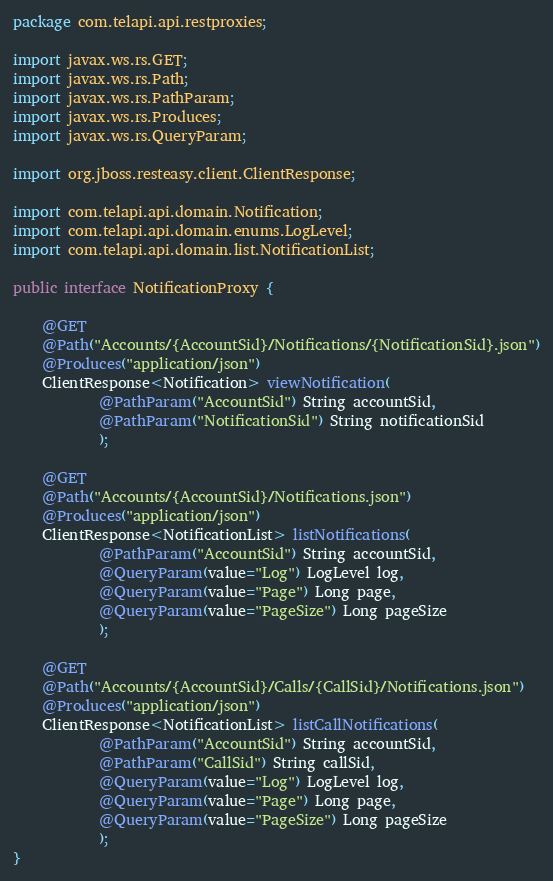Convert code to text. <code><loc_0><loc_0><loc_500><loc_500><_Java_>package com.telapi.api.restproxies;

import javax.ws.rs.GET;
import javax.ws.rs.Path;
import javax.ws.rs.PathParam;
import javax.ws.rs.Produces;
import javax.ws.rs.QueryParam;

import org.jboss.resteasy.client.ClientResponse;

import com.telapi.api.domain.Notification;
import com.telapi.api.domain.enums.LogLevel;
import com.telapi.api.domain.list.NotificationList;

public interface NotificationProxy {

	@GET
	@Path("Accounts/{AccountSid}/Notifications/{NotificationSid}.json")
	@Produces("application/json")
	ClientResponse<Notification> viewNotification(
			@PathParam("AccountSid") String accountSid,
			@PathParam("NotificationSid") String notificationSid
			);
	
	@GET
	@Path("Accounts/{AccountSid}/Notifications.json")
	@Produces("application/json")
	ClientResponse<NotificationList> listNotifications(
			@PathParam("AccountSid") String accountSid,
			@QueryParam(value="Log") LogLevel log,
			@QueryParam(value="Page") Long page,
    		@QueryParam(value="PageSize") Long pageSize
			);
	
	@GET
	@Path("Accounts/{AccountSid}/Calls/{CallSid}/Notifications.json")
	@Produces("application/json")
	ClientResponse<NotificationList> listCallNotifications(
			@PathParam("AccountSid") String accountSid,
			@PathParam("CallSid") String callSid,
			@QueryParam(value="Log") LogLevel log,
			@QueryParam(value="Page") Long page,
    		@QueryParam(value="PageSize") Long pageSize
			);
}
</code> 